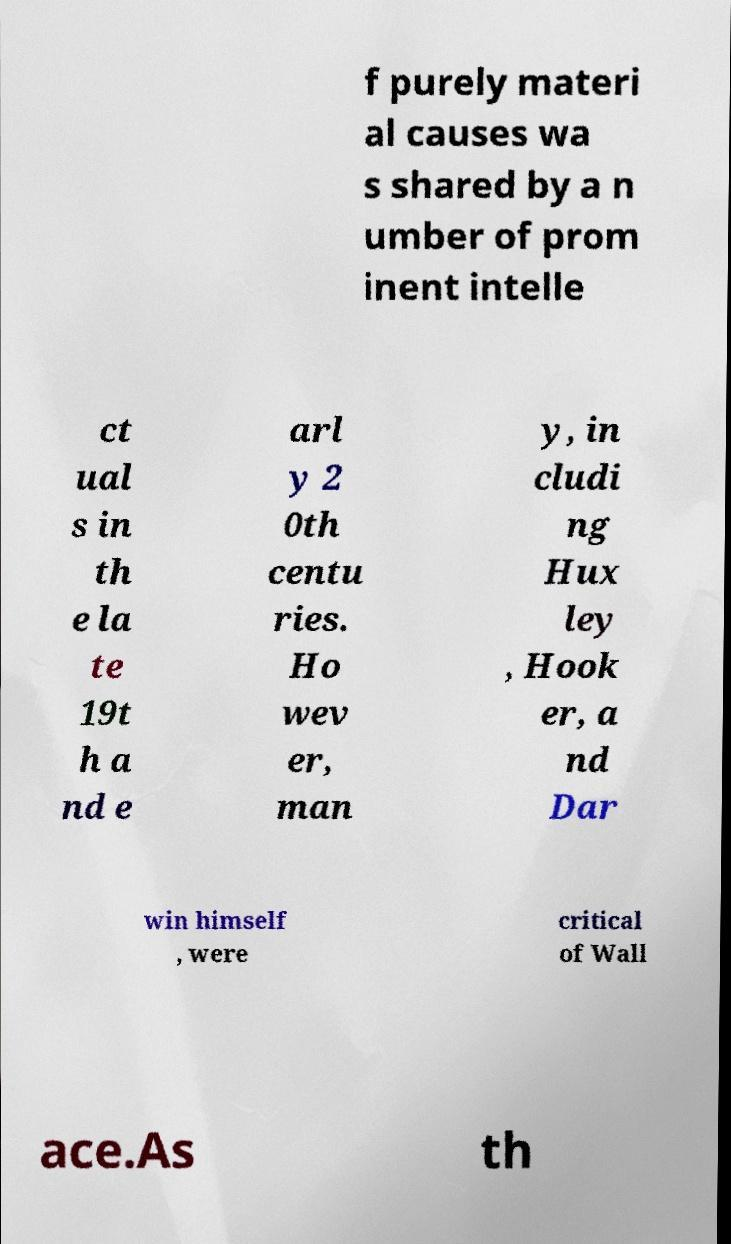Could you assist in decoding the text presented in this image and type it out clearly? f purely materi al causes wa s shared by a n umber of prom inent intelle ct ual s in th e la te 19t h a nd e arl y 2 0th centu ries. Ho wev er, man y, in cludi ng Hux ley , Hook er, a nd Dar win himself , were critical of Wall ace.As th 